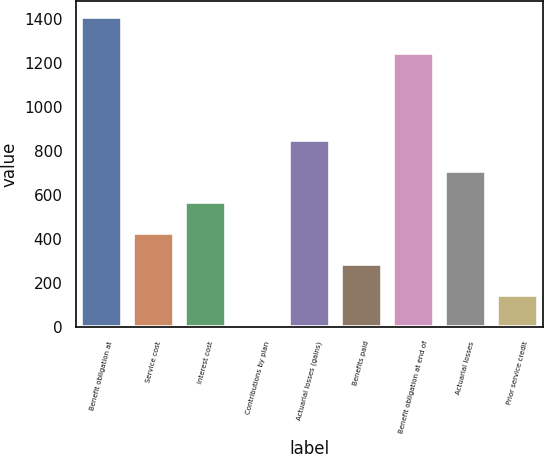Convert chart. <chart><loc_0><loc_0><loc_500><loc_500><bar_chart><fcel>Benefit obligation at<fcel>Service cost<fcel>Interest cost<fcel>Contributions by plan<fcel>Actuarial losses (gains)<fcel>Benefits paid<fcel>Benefit obligation at end of<fcel>Actuarial losses<fcel>Prior service credit<nl><fcel>1410<fcel>427.2<fcel>567.6<fcel>6<fcel>848.4<fcel>286.8<fcel>1247<fcel>708<fcel>146.4<nl></chart> 